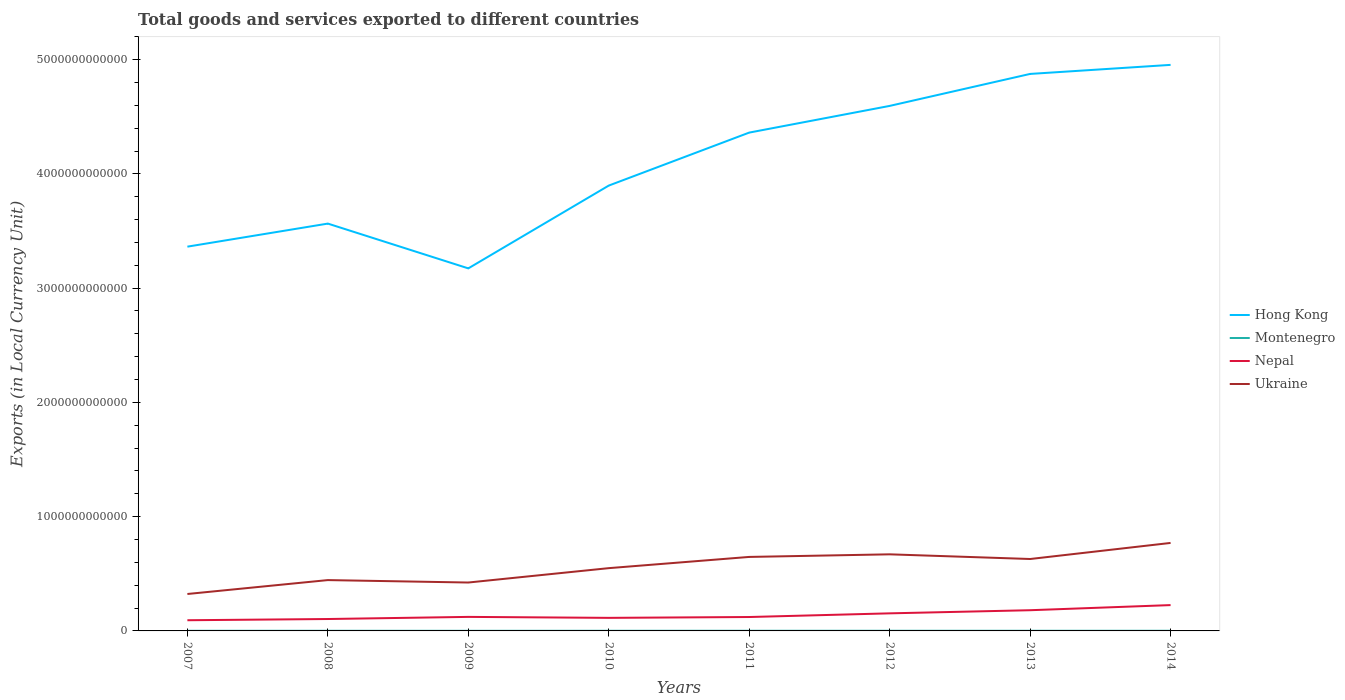How many different coloured lines are there?
Give a very brief answer. 4. Across all years, what is the maximum Amount of goods and services exports in Ukraine?
Provide a short and direct response. 3.23e+11. In which year was the Amount of goods and services exports in Nepal maximum?
Keep it short and to the point. 2007. What is the total Amount of goods and services exports in Montenegro in the graph?
Your answer should be very brief. -2.82e+07. What is the difference between the highest and the second highest Amount of goods and services exports in Montenegro?
Provide a short and direct response. 4.33e+08. What is the difference between the highest and the lowest Amount of goods and services exports in Montenegro?
Your answer should be compact. 4. How many lines are there?
Offer a very short reply. 4. What is the difference between two consecutive major ticks on the Y-axis?
Provide a short and direct response. 1.00e+12. Are the values on the major ticks of Y-axis written in scientific E-notation?
Keep it short and to the point. No. Does the graph contain any zero values?
Keep it short and to the point. No. Does the graph contain grids?
Your response must be concise. No. How are the legend labels stacked?
Your answer should be very brief. Vertical. What is the title of the graph?
Give a very brief answer. Total goods and services exported to different countries. Does "Tonga" appear as one of the legend labels in the graph?
Provide a short and direct response. No. What is the label or title of the Y-axis?
Give a very brief answer. Exports (in Local Currency Unit). What is the Exports (in Local Currency Unit) of Hong Kong in 2007?
Your response must be concise. 3.36e+12. What is the Exports (in Local Currency Unit) of Montenegro in 2007?
Your answer should be compact. 1.19e+09. What is the Exports (in Local Currency Unit) in Nepal in 2007?
Provide a succinct answer. 9.36e+1. What is the Exports (in Local Currency Unit) in Ukraine in 2007?
Provide a succinct answer. 3.23e+11. What is the Exports (in Local Currency Unit) in Hong Kong in 2008?
Offer a terse response. 3.56e+12. What is the Exports (in Local Currency Unit) of Montenegro in 2008?
Your response must be concise. 1.22e+09. What is the Exports (in Local Currency Unit) of Nepal in 2008?
Offer a very short reply. 1.04e+11. What is the Exports (in Local Currency Unit) of Ukraine in 2008?
Offer a terse response. 4.45e+11. What is the Exports (in Local Currency Unit) of Hong Kong in 2009?
Your response must be concise. 3.17e+12. What is the Exports (in Local Currency Unit) of Montenegro in 2009?
Your response must be concise. 9.57e+08. What is the Exports (in Local Currency Unit) of Nepal in 2009?
Offer a terse response. 1.23e+11. What is the Exports (in Local Currency Unit) in Ukraine in 2009?
Your answer should be compact. 4.24e+11. What is the Exports (in Local Currency Unit) of Hong Kong in 2010?
Provide a short and direct response. 3.90e+12. What is the Exports (in Local Currency Unit) in Montenegro in 2010?
Provide a succinct answer. 1.16e+09. What is the Exports (in Local Currency Unit) in Nepal in 2010?
Offer a terse response. 1.14e+11. What is the Exports (in Local Currency Unit) of Ukraine in 2010?
Give a very brief answer. 5.49e+11. What is the Exports (in Local Currency Unit) of Hong Kong in 2011?
Make the answer very short. 4.36e+12. What is the Exports (in Local Currency Unit) in Montenegro in 2011?
Make the answer very short. 1.38e+09. What is the Exports (in Local Currency Unit) of Nepal in 2011?
Make the answer very short. 1.22e+11. What is the Exports (in Local Currency Unit) of Ukraine in 2011?
Make the answer very short. 6.48e+11. What is the Exports (in Local Currency Unit) in Hong Kong in 2012?
Your answer should be very brief. 4.59e+12. What is the Exports (in Local Currency Unit) of Montenegro in 2012?
Keep it short and to the point. 1.39e+09. What is the Exports (in Local Currency Unit) in Nepal in 2012?
Give a very brief answer. 1.54e+11. What is the Exports (in Local Currency Unit) in Ukraine in 2012?
Your response must be concise. 6.70e+11. What is the Exports (in Local Currency Unit) in Hong Kong in 2013?
Your answer should be very brief. 4.87e+12. What is the Exports (in Local Currency Unit) of Montenegro in 2013?
Offer a very short reply. 1.39e+09. What is the Exports (in Local Currency Unit) in Nepal in 2013?
Provide a short and direct response. 1.81e+11. What is the Exports (in Local Currency Unit) in Ukraine in 2013?
Give a very brief answer. 6.29e+11. What is the Exports (in Local Currency Unit) in Hong Kong in 2014?
Offer a terse response. 4.95e+12. What is the Exports (in Local Currency Unit) in Montenegro in 2014?
Ensure brevity in your answer.  1.39e+09. What is the Exports (in Local Currency Unit) of Nepal in 2014?
Provide a short and direct response. 2.26e+11. What is the Exports (in Local Currency Unit) in Ukraine in 2014?
Your response must be concise. 7.70e+11. Across all years, what is the maximum Exports (in Local Currency Unit) of Hong Kong?
Keep it short and to the point. 4.95e+12. Across all years, what is the maximum Exports (in Local Currency Unit) in Montenegro?
Your answer should be very brief. 1.39e+09. Across all years, what is the maximum Exports (in Local Currency Unit) in Nepal?
Provide a succinct answer. 2.26e+11. Across all years, what is the maximum Exports (in Local Currency Unit) of Ukraine?
Your answer should be compact. 7.70e+11. Across all years, what is the minimum Exports (in Local Currency Unit) in Hong Kong?
Keep it short and to the point. 3.17e+12. Across all years, what is the minimum Exports (in Local Currency Unit) in Montenegro?
Your answer should be compact. 9.57e+08. Across all years, what is the minimum Exports (in Local Currency Unit) of Nepal?
Keep it short and to the point. 9.36e+1. Across all years, what is the minimum Exports (in Local Currency Unit) in Ukraine?
Ensure brevity in your answer.  3.23e+11. What is the total Exports (in Local Currency Unit) in Hong Kong in the graph?
Ensure brevity in your answer.  3.28e+13. What is the total Exports (in Local Currency Unit) in Montenegro in the graph?
Offer a very short reply. 1.01e+1. What is the total Exports (in Local Currency Unit) of Nepal in the graph?
Your answer should be very brief. 1.12e+12. What is the total Exports (in Local Currency Unit) in Ukraine in the graph?
Offer a terse response. 4.46e+12. What is the difference between the Exports (in Local Currency Unit) of Hong Kong in 2007 and that in 2008?
Make the answer very short. -2.02e+11. What is the difference between the Exports (in Local Currency Unit) in Montenegro in 2007 and that in 2008?
Your answer should be compact. -2.82e+07. What is the difference between the Exports (in Local Currency Unit) of Nepal in 2007 and that in 2008?
Your answer should be compact. -1.06e+1. What is the difference between the Exports (in Local Currency Unit) of Ukraine in 2007 and that in 2008?
Your response must be concise. -1.22e+11. What is the difference between the Exports (in Local Currency Unit) in Hong Kong in 2007 and that in 2009?
Offer a very short reply. 1.90e+11. What is the difference between the Exports (in Local Currency Unit) in Montenegro in 2007 and that in 2009?
Your response must be concise. 2.32e+08. What is the difference between the Exports (in Local Currency Unit) in Nepal in 2007 and that in 2009?
Your answer should be compact. -2.92e+1. What is the difference between the Exports (in Local Currency Unit) of Ukraine in 2007 and that in 2009?
Offer a very short reply. -1.00e+11. What is the difference between the Exports (in Local Currency Unit) of Hong Kong in 2007 and that in 2010?
Your answer should be compact. -5.35e+11. What is the difference between the Exports (in Local Currency Unit) of Montenegro in 2007 and that in 2010?
Offer a very short reply. 3.23e+07. What is the difference between the Exports (in Local Currency Unit) in Nepal in 2007 and that in 2010?
Provide a short and direct response. -2.07e+1. What is the difference between the Exports (in Local Currency Unit) in Ukraine in 2007 and that in 2010?
Ensure brevity in your answer.  -2.26e+11. What is the difference between the Exports (in Local Currency Unit) of Hong Kong in 2007 and that in 2011?
Offer a terse response. -9.98e+11. What is the difference between the Exports (in Local Currency Unit) in Montenegro in 2007 and that in 2011?
Your answer should be compact. -1.93e+08. What is the difference between the Exports (in Local Currency Unit) in Nepal in 2007 and that in 2011?
Make the answer very short. -2.81e+1. What is the difference between the Exports (in Local Currency Unit) of Ukraine in 2007 and that in 2011?
Keep it short and to the point. -3.24e+11. What is the difference between the Exports (in Local Currency Unit) in Hong Kong in 2007 and that in 2012?
Your answer should be very brief. -1.23e+12. What is the difference between the Exports (in Local Currency Unit) of Montenegro in 2007 and that in 2012?
Provide a succinct answer. -1.99e+08. What is the difference between the Exports (in Local Currency Unit) of Nepal in 2007 and that in 2012?
Keep it short and to the point. -6.03e+1. What is the difference between the Exports (in Local Currency Unit) of Ukraine in 2007 and that in 2012?
Provide a succinct answer. -3.47e+11. What is the difference between the Exports (in Local Currency Unit) of Hong Kong in 2007 and that in 2013?
Make the answer very short. -1.51e+12. What is the difference between the Exports (in Local Currency Unit) in Montenegro in 2007 and that in 2013?
Give a very brief answer. -2.00e+08. What is the difference between the Exports (in Local Currency Unit) in Nepal in 2007 and that in 2013?
Your response must be concise. -8.76e+1. What is the difference between the Exports (in Local Currency Unit) in Ukraine in 2007 and that in 2013?
Offer a terse response. -3.06e+11. What is the difference between the Exports (in Local Currency Unit) in Hong Kong in 2007 and that in 2014?
Make the answer very short. -1.59e+12. What is the difference between the Exports (in Local Currency Unit) of Montenegro in 2007 and that in 2014?
Your answer should be compact. -1.98e+08. What is the difference between the Exports (in Local Currency Unit) in Nepal in 2007 and that in 2014?
Provide a short and direct response. -1.32e+11. What is the difference between the Exports (in Local Currency Unit) in Ukraine in 2007 and that in 2014?
Offer a terse response. -4.47e+11. What is the difference between the Exports (in Local Currency Unit) of Hong Kong in 2008 and that in 2009?
Your answer should be very brief. 3.92e+11. What is the difference between the Exports (in Local Currency Unit) of Montenegro in 2008 and that in 2009?
Provide a succinct answer. 2.61e+08. What is the difference between the Exports (in Local Currency Unit) of Nepal in 2008 and that in 2009?
Give a very brief answer. -1.85e+1. What is the difference between the Exports (in Local Currency Unit) of Ukraine in 2008 and that in 2009?
Offer a very short reply. 2.13e+1. What is the difference between the Exports (in Local Currency Unit) in Hong Kong in 2008 and that in 2010?
Give a very brief answer. -3.33e+11. What is the difference between the Exports (in Local Currency Unit) in Montenegro in 2008 and that in 2010?
Provide a short and direct response. 6.05e+07. What is the difference between the Exports (in Local Currency Unit) of Nepal in 2008 and that in 2010?
Offer a terse response. -1.01e+1. What is the difference between the Exports (in Local Currency Unit) of Ukraine in 2008 and that in 2010?
Provide a short and direct response. -1.05e+11. What is the difference between the Exports (in Local Currency Unit) of Hong Kong in 2008 and that in 2011?
Provide a short and direct response. -7.96e+11. What is the difference between the Exports (in Local Currency Unit) of Montenegro in 2008 and that in 2011?
Your response must be concise. -1.64e+08. What is the difference between the Exports (in Local Currency Unit) in Nepal in 2008 and that in 2011?
Offer a terse response. -1.75e+1. What is the difference between the Exports (in Local Currency Unit) of Ukraine in 2008 and that in 2011?
Offer a very short reply. -2.03e+11. What is the difference between the Exports (in Local Currency Unit) in Hong Kong in 2008 and that in 2012?
Your response must be concise. -1.03e+12. What is the difference between the Exports (in Local Currency Unit) in Montenegro in 2008 and that in 2012?
Ensure brevity in your answer.  -1.71e+08. What is the difference between the Exports (in Local Currency Unit) of Nepal in 2008 and that in 2012?
Make the answer very short. -4.97e+1. What is the difference between the Exports (in Local Currency Unit) in Ukraine in 2008 and that in 2012?
Provide a short and direct response. -2.25e+11. What is the difference between the Exports (in Local Currency Unit) in Hong Kong in 2008 and that in 2013?
Ensure brevity in your answer.  -1.31e+12. What is the difference between the Exports (in Local Currency Unit) in Montenegro in 2008 and that in 2013?
Your answer should be very brief. -1.72e+08. What is the difference between the Exports (in Local Currency Unit) of Nepal in 2008 and that in 2013?
Ensure brevity in your answer.  -7.70e+1. What is the difference between the Exports (in Local Currency Unit) in Ukraine in 2008 and that in 2013?
Your response must be concise. -1.85e+11. What is the difference between the Exports (in Local Currency Unit) of Hong Kong in 2008 and that in 2014?
Ensure brevity in your answer.  -1.39e+12. What is the difference between the Exports (in Local Currency Unit) in Montenegro in 2008 and that in 2014?
Keep it short and to the point. -1.70e+08. What is the difference between the Exports (in Local Currency Unit) of Nepal in 2008 and that in 2014?
Give a very brief answer. -1.22e+11. What is the difference between the Exports (in Local Currency Unit) in Ukraine in 2008 and that in 2014?
Provide a succinct answer. -3.25e+11. What is the difference between the Exports (in Local Currency Unit) of Hong Kong in 2009 and that in 2010?
Provide a succinct answer. -7.25e+11. What is the difference between the Exports (in Local Currency Unit) in Montenegro in 2009 and that in 2010?
Provide a succinct answer. -2.00e+08. What is the difference between the Exports (in Local Currency Unit) of Nepal in 2009 and that in 2010?
Your answer should be compact. 8.44e+09. What is the difference between the Exports (in Local Currency Unit) in Ukraine in 2009 and that in 2010?
Offer a very short reply. -1.26e+11. What is the difference between the Exports (in Local Currency Unit) of Hong Kong in 2009 and that in 2011?
Your answer should be very brief. -1.19e+12. What is the difference between the Exports (in Local Currency Unit) in Montenegro in 2009 and that in 2011?
Provide a short and direct response. -4.25e+08. What is the difference between the Exports (in Local Currency Unit) in Nepal in 2009 and that in 2011?
Provide a short and direct response. 1.02e+09. What is the difference between the Exports (in Local Currency Unit) of Ukraine in 2009 and that in 2011?
Make the answer very short. -2.24e+11. What is the difference between the Exports (in Local Currency Unit) of Hong Kong in 2009 and that in 2012?
Your response must be concise. -1.42e+12. What is the difference between the Exports (in Local Currency Unit) in Montenegro in 2009 and that in 2012?
Make the answer very short. -4.32e+08. What is the difference between the Exports (in Local Currency Unit) of Nepal in 2009 and that in 2012?
Your answer should be very brief. -3.11e+1. What is the difference between the Exports (in Local Currency Unit) in Ukraine in 2009 and that in 2012?
Keep it short and to the point. -2.47e+11. What is the difference between the Exports (in Local Currency Unit) of Hong Kong in 2009 and that in 2013?
Keep it short and to the point. -1.70e+12. What is the difference between the Exports (in Local Currency Unit) of Montenegro in 2009 and that in 2013?
Give a very brief answer. -4.33e+08. What is the difference between the Exports (in Local Currency Unit) of Nepal in 2009 and that in 2013?
Make the answer very short. -5.84e+1. What is the difference between the Exports (in Local Currency Unit) of Ukraine in 2009 and that in 2013?
Offer a very short reply. -2.06e+11. What is the difference between the Exports (in Local Currency Unit) in Hong Kong in 2009 and that in 2014?
Keep it short and to the point. -1.78e+12. What is the difference between the Exports (in Local Currency Unit) in Montenegro in 2009 and that in 2014?
Your answer should be compact. -4.31e+08. What is the difference between the Exports (in Local Currency Unit) in Nepal in 2009 and that in 2014?
Ensure brevity in your answer.  -1.03e+11. What is the difference between the Exports (in Local Currency Unit) in Ukraine in 2009 and that in 2014?
Provide a succinct answer. -3.47e+11. What is the difference between the Exports (in Local Currency Unit) of Hong Kong in 2010 and that in 2011?
Give a very brief answer. -4.64e+11. What is the difference between the Exports (in Local Currency Unit) in Montenegro in 2010 and that in 2011?
Offer a very short reply. -2.25e+08. What is the difference between the Exports (in Local Currency Unit) in Nepal in 2010 and that in 2011?
Your answer should be compact. -7.42e+09. What is the difference between the Exports (in Local Currency Unit) in Ukraine in 2010 and that in 2011?
Ensure brevity in your answer.  -9.82e+1. What is the difference between the Exports (in Local Currency Unit) of Hong Kong in 2010 and that in 2012?
Offer a very short reply. -6.97e+11. What is the difference between the Exports (in Local Currency Unit) in Montenegro in 2010 and that in 2012?
Give a very brief answer. -2.32e+08. What is the difference between the Exports (in Local Currency Unit) in Nepal in 2010 and that in 2012?
Make the answer very short. -3.96e+1. What is the difference between the Exports (in Local Currency Unit) in Ukraine in 2010 and that in 2012?
Keep it short and to the point. -1.21e+11. What is the difference between the Exports (in Local Currency Unit) in Hong Kong in 2010 and that in 2013?
Provide a succinct answer. -9.77e+11. What is the difference between the Exports (in Local Currency Unit) of Montenegro in 2010 and that in 2013?
Your answer should be very brief. -2.32e+08. What is the difference between the Exports (in Local Currency Unit) in Nepal in 2010 and that in 2013?
Make the answer very short. -6.69e+1. What is the difference between the Exports (in Local Currency Unit) of Ukraine in 2010 and that in 2013?
Your answer should be compact. -8.00e+1. What is the difference between the Exports (in Local Currency Unit) in Hong Kong in 2010 and that in 2014?
Your answer should be very brief. -1.06e+12. What is the difference between the Exports (in Local Currency Unit) of Montenegro in 2010 and that in 2014?
Keep it short and to the point. -2.30e+08. What is the difference between the Exports (in Local Currency Unit) of Nepal in 2010 and that in 2014?
Your answer should be compact. -1.12e+11. What is the difference between the Exports (in Local Currency Unit) in Ukraine in 2010 and that in 2014?
Your answer should be very brief. -2.21e+11. What is the difference between the Exports (in Local Currency Unit) in Hong Kong in 2011 and that in 2012?
Keep it short and to the point. -2.34e+11. What is the difference between the Exports (in Local Currency Unit) of Montenegro in 2011 and that in 2012?
Your answer should be compact. -6.83e+06. What is the difference between the Exports (in Local Currency Unit) of Nepal in 2011 and that in 2012?
Offer a terse response. -3.21e+1. What is the difference between the Exports (in Local Currency Unit) in Ukraine in 2011 and that in 2012?
Provide a succinct answer. -2.27e+1. What is the difference between the Exports (in Local Currency Unit) of Hong Kong in 2011 and that in 2013?
Make the answer very short. -5.13e+11. What is the difference between the Exports (in Local Currency Unit) of Montenegro in 2011 and that in 2013?
Offer a very short reply. -7.53e+06. What is the difference between the Exports (in Local Currency Unit) in Nepal in 2011 and that in 2013?
Your answer should be very brief. -5.95e+1. What is the difference between the Exports (in Local Currency Unit) in Ukraine in 2011 and that in 2013?
Your response must be concise. 1.82e+1. What is the difference between the Exports (in Local Currency Unit) in Hong Kong in 2011 and that in 2014?
Make the answer very short. -5.93e+11. What is the difference between the Exports (in Local Currency Unit) in Montenegro in 2011 and that in 2014?
Your answer should be very brief. -5.54e+06. What is the difference between the Exports (in Local Currency Unit) of Nepal in 2011 and that in 2014?
Offer a terse response. -1.04e+11. What is the difference between the Exports (in Local Currency Unit) in Ukraine in 2011 and that in 2014?
Your answer should be compact. -1.23e+11. What is the difference between the Exports (in Local Currency Unit) in Hong Kong in 2012 and that in 2013?
Make the answer very short. -2.80e+11. What is the difference between the Exports (in Local Currency Unit) of Montenegro in 2012 and that in 2013?
Offer a very short reply. -6.99e+05. What is the difference between the Exports (in Local Currency Unit) of Nepal in 2012 and that in 2013?
Offer a very short reply. -2.73e+1. What is the difference between the Exports (in Local Currency Unit) of Ukraine in 2012 and that in 2013?
Offer a terse response. 4.09e+1. What is the difference between the Exports (in Local Currency Unit) of Hong Kong in 2012 and that in 2014?
Keep it short and to the point. -3.59e+11. What is the difference between the Exports (in Local Currency Unit) of Montenegro in 2012 and that in 2014?
Your answer should be compact. 1.29e+06. What is the difference between the Exports (in Local Currency Unit) of Nepal in 2012 and that in 2014?
Your answer should be compact. -7.22e+1. What is the difference between the Exports (in Local Currency Unit) of Ukraine in 2012 and that in 2014?
Offer a very short reply. -9.98e+1. What is the difference between the Exports (in Local Currency Unit) of Hong Kong in 2013 and that in 2014?
Make the answer very short. -7.92e+1. What is the difference between the Exports (in Local Currency Unit) in Montenegro in 2013 and that in 2014?
Make the answer very short. 1.99e+06. What is the difference between the Exports (in Local Currency Unit) of Nepal in 2013 and that in 2014?
Ensure brevity in your answer.  -4.48e+1. What is the difference between the Exports (in Local Currency Unit) of Ukraine in 2013 and that in 2014?
Your answer should be compact. -1.41e+11. What is the difference between the Exports (in Local Currency Unit) in Hong Kong in 2007 and the Exports (in Local Currency Unit) in Montenegro in 2008?
Ensure brevity in your answer.  3.36e+12. What is the difference between the Exports (in Local Currency Unit) of Hong Kong in 2007 and the Exports (in Local Currency Unit) of Nepal in 2008?
Provide a short and direct response. 3.26e+12. What is the difference between the Exports (in Local Currency Unit) in Hong Kong in 2007 and the Exports (in Local Currency Unit) in Ukraine in 2008?
Offer a terse response. 2.92e+12. What is the difference between the Exports (in Local Currency Unit) of Montenegro in 2007 and the Exports (in Local Currency Unit) of Nepal in 2008?
Offer a terse response. -1.03e+11. What is the difference between the Exports (in Local Currency Unit) in Montenegro in 2007 and the Exports (in Local Currency Unit) in Ukraine in 2008?
Make the answer very short. -4.44e+11. What is the difference between the Exports (in Local Currency Unit) of Nepal in 2007 and the Exports (in Local Currency Unit) of Ukraine in 2008?
Provide a succinct answer. -3.51e+11. What is the difference between the Exports (in Local Currency Unit) of Hong Kong in 2007 and the Exports (in Local Currency Unit) of Montenegro in 2009?
Provide a short and direct response. 3.36e+12. What is the difference between the Exports (in Local Currency Unit) of Hong Kong in 2007 and the Exports (in Local Currency Unit) of Nepal in 2009?
Provide a succinct answer. 3.24e+12. What is the difference between the Exports (in Local Currency Unit) of Hong Kong in 2007 and the Exports (in Local Currency Unit) of Ukraine in 2009?
Your answer should be compact. 2.94e+12. What is the difference between the Exports (in Local Currency Unit) in Montenegro in 2007 and the Exports (in Local Currency Unit) in Nepal in 2009?
Make the answer very short. -1.22e+11. What is the difference between the Exports (in Local Currency Unit) in Montenegro in 2007 and the Exports (in Local Currency Unit) in Ukraine in 2009?
Provide a succinct answer. -4.22e+11. What is the difference between the Exports (in Local Currency Unit) of Nepal in 2007 and the Exports (in Local Currency Unit) of Ukraine in 2009?
Your response must be concise. -3.30e+11. What is the difference between the Exports (in Local Currency Unit) in Hong Kong in 2007 and the Exports (in Local Currency Unit) in Montenegro in 2010?
Make the answer very short. 3.36e+12. What is the difference between the Exports (in Local Currency Unit) in Hong Kong in 2007 and the Exports (in Local Currency Unit) in Nepal in 2010?
Your response must be concise. 3.25e+12. What is the difference between the Exports (in Local Currency Unit) of Hong Kong in 2007 and the Exports (in Local Currency Unit) of Ukraine in 2010?
Keep it short and to the point. 2.81e+12. What is the difference between the Exports (in Local Currency Unit) of Montenegro in 2007 and the Exports (in Local Currency Unit) of Nepal in 2010?
Give a very brief answer. -1.13e+11. What is the difference between the Exports (in Local Currency Unit) in Montenegro in 2007 and the Exports (in Local Currency Unit) in Ukraine in 2010?
Make the answer very short. -5.48e+11. What is the difference between the Exports (in Local Currency Unit) of Nepal in 2007 and the Exports (in Local Currency Unit) of Ukraine in 2010?
Your answer should be very brief. -4.56e+11. What is the difference between the Exports (in Local Currency Unit) of Hong Kong in 2007 and the Exports (in Local Currency Unit) of Montenegro in 2011?
Your answer should be very brief. 3.36e+12. What is the difference between the Exports (in Local Currency Unit) in Hong Kong in 2007 and the Exports (in Local Currency Unit) in Nepal in 2011?
Ensure brevity in your answer.  3.24e+12. What is the difference between the Exports (in Local Currency Unit) of Hong Kong in 2007 and the Exports (in Local Currency Unit) of Ukraine in 2011?
Your response must be concise. 2.72e+12. What is the difference between the Exports (in Local Currency Unit) in Montenegro in 2007 and the Exports (in Local Currency Unit) in Nepal in 2011?
Provide a short and direct response. -1.21e+11. What is the difference between the Exports (in Local Currency Unit) in Montenegro in 2007 and the Exports (in Local Currency Unit) in Ukraine in 2011?
Offer a terse response. -6.46e+11. What is the difference between the Exports (in Local Currency Unit) in Nepal in 2007 and the Exports (in Local Currency Unit) in Ukraine in 2011?
Ensure brevity in your answer.  -5.54e+11. What is the difference between the Exports (in Local Currency Unit) of Hong Kong in 2007 and the Exports (in Local Currency Unit) of Montenegro in 2012?
Give a very brief answer. 3.36e+12. What is the difference between the Exports (in Local Currency Unit) in Hong Kong in 2007 and the Exports (in Local Currency Unit) in Nepal in 2012?
Offer a very short reply. 3.21e+12. What is the difference between the Exports (in Local Currency Unit) of Hong Kong in 2007 and the Exports (in Local Currency Unit) of Ukraine in 2012?
Provide a succinct answer. 2.69e+12. What is the difference between the Exports (in Local Currency Unit) in Montenegro in 2007 and the Exports (in Local Currency Unit) in Nepal in 2012?
Your answer should be compact. -1.53e+11. What is the difference between the Exports (in Local Currency Unit) in Montenegro in 2007 and the Exports (in Local Currency Unit) in Ukraine in 2012?
Provide a succinct answer. -6.69e+11. What is the difference between the Exports (in Local Currency Unit) in Nepal in 2007 and the Exports (in Local Currency Unit) in Ukraine in 2012?
Offer a terse response. -5.77e+11. What is the difference between the Exports (in Local Currency Unit) in Hong Kong in 2007 and the Exports (in Local Currency Unit) in Montenegro in 2013?
Your answer should be very brief. 3.36e+12. What is the difference between the Exports (in Local Currency Unit) in Hong Kong in 2007 and the Exports (in Local Currency Unit) in Nepal in 2013?
Make the answer very short. 3.18e+12. What is the difference between the Exports (in Local Currency Unit) of Hong Kong in 2007 and the Exports (in Local Currency Unit) of Ukraine in 2013?
Provide a succinct answer. 2.73e+12. What is the difference between the Exports (in Local Currency Unit) of Montenegro in 2007 and the Exports (in Local Currency Unit) of Nepal in 2013?
Offer a terse response. -1.80e+11. What is the difference between the Exports (in Local Currency Unit) of Montenegro in 2007 and the Exports (in Local Currency Unit) of Ukraine in 2013?
Provide a short and direct response. -6.28e+11. What is the difference between the Exports (in Local Currency Unit) in Nepal in 2007 and the Exports (in Local Currency Unit) in Ukraine in 2013?
Your answer should be very brief. -5.36e+11. What is the difference between the Exports (in Local Currency Unit) in Hong Kong in 2007 and the Exports (in Local Currency Unit) in Montenegro in 2014?
Provide a succinct answer. 3.36e+12. What is the difference between the Exports (in Local Currency Unit) of Hong Kong in 2007 and the Exports (in Local Currency Unit) of Nepal in 2014?
Provide a succinct answer. 3.14e+12. What is the difference between the Exports (in Local Currency Unit) of Hong Kong in 2007 and the Exports (in Local Currency Unit) of Ukraine in 2014?
Ensure brevity in your answer.  2.59e+12. What is the difference between the Exports (in Local Currency Unit) of Montenegro in 2007 and the Exports (in Local Currency Unit) of Nepal in 2014?
Provide a succinct answer. -2.25e+11. What is the difference between the Exports (in Local Currency Unit) in Montenegro in 2007 and the Exports (in Local Currency Unit) in Ukraine in 2014?
Offer a very short reply. -7.69e+11. What is the difference between the Exports (in Local Currency Unit) of Nepal in 2007 and the Exports (in Local Currency Unit) of Ukraine in 2014?
Give a very brief answer. -6.77e+11. What is the difference between the Exports (in Local Currency Unit) in Hong Kong in 2008 and the Exports (in Local Currency Unit) in Montenegro in 2009?
Provide a short and direct response. 3.56e+12. What is the difference between the Exports (in Local Currency Unit) of Hong Kong in 2008 and the Exports (in Local Currency Unit) of Nepal in 2009?
Provide a short and direct response. 3.44e+12. What is the difference between the Exports (in Local Currency Unit) in Hong Kong in 2008 and the Exports (in Local Currency Unit) in Ukraine in 2009?
Offer a terse response. 3.14e+12. What is the difference between the Exports (in Local Currency Unit) in Montenegro in 2008 and the Exports (in Local Currency Unit) in Nepal in 2009?
Your response must be concise. -1.22e+11. What is the difference between the Exports (in Local Currency Unit) in Montenegro in 2008 and the Exports (in Local Currency Unit) in Ukraine in 2009?
Your response must be concise. -4.22e+11. What is the difference between the Exports (in Local Currency Unit) in Nepal in 2008 and the Exports (in Local Currency Unit) in Ukraine in 2009?
Your response must be concise. -3.19e+11. What is the difference between the Exports (in Local Currency Unit) of Hong Kong in 2008 and the Exports (in Local Currency Unit) of Montenegro in 2010?
Ensure brevity in your answer.  3.56e+12. What is the difference between the Exports (in Local Currency Unit) in Hong Kong in 2008 and the Exports (in Local Currency Unit) in Nepal in 2010?
Your response must be concise. 3.45e+12. What is the difference between the Exports (in Local Currency Unit) in Hong Kong in 2008 and the Exports (in Local Currency Unit) in Ukraine in 2010?
Provide a succinct answer. 3.02e+12. What is the difference between the Exports (in Local Currency Unit) of Montenegro in 2008 and the Exports (in Local Currency Unit) of Nepal in 2010?
Make the answer very short. -1.13e+11. What is the difference between the Exports (in Local Currency Unit) in Montenegro in 2008 and the Exports (in Local Currency Unit) in Ukraine in 2010?
Give a very brief answer. -5.48e+11. What is the difference between the Exports (in Local Currency Unit) of Nepal in 2008 and the Exports (in Local Currency Unit) of Ukraine in 2010?
Your response must be concise. -4.45e+11. What is the difference between the Exports (in Local Currency Unit) in Hong Kong in 2008 and the Exports (in Local Currency Unit) in Montenegro in 2011?
Provide a short and direct response. 3.56e+12. What is the difference between the Exports (in Local Currency Unit) in Hong Kong in 2008 and the Exports (in Local Currency Unit) in Nepal in 2011?
Ensure brevity in your answer.  3.44e+12. What is the difference between the Exports (in Local Currency Unit) of Hong Kong in 2008 and the Exports (in Local Currency Unit) of Ukraine in 2011?
Your response must be concise. 2.92e+12. What is the difference between the Exports (in Local Currency Unit) in Montenegro in 2008 and the Exports (in Local Currency Unit) in Nepal in 2011?
Keep it short and to the point. -1.20e+11. What is the difference between the Exports (in Local Currency Unit) in Montenegro in 2008 and the Exports (in Local Currency Unit) in Ukraine in 2011?
Your answer should be compact. -6.46e+11. What is the difference between the Exports (in Local Currency Unit) in Nepal in 2008 and the Exports (in Local Currency Unit) in Ukraine in 2011?
Provide a short and direct response. -5.43e+11. What is the difference between the Exports (in Local Currency Unit) of Hong Kong in 2008 and the Exports (in Local Currency Unit) of Montenegro in 2012?
Your answer should be very brief. 3.56e+12. What is the difference between the Exports (in Local Currency Unit) in Hong Kong in 2008 and the Exports (in Local Currency Unit) in Nepal in 2012?
Your answer should be very brief. 3.41e+12. What is the difference between the Exports (in Local Currency Unit) of Hong Kong in 2008 and the Exports (in Local Currency Unit) of Ukraine in 2012?
Offer a very short reply. 2.89e+12. What is the difference between the Exports (in Local Currency Unit) of Montenegro in 2008 and the Exports (in Local Currency Unit) of Nepal in 2012?
Make the answer very short. -1.53e+11. What is the difference between the Exports (in Local Currency Unit) of Montenegro in 2008 and the Exports (in Local Currency Unit) of Ukraine in 2012?
Provide a short and direct response. -6.69e+11. What is the difference between the Exports (in Local Currency Unit) in Nepal in 2008 and the Exports (in Local Currency Unit) in Ukraine in 2012?
Offer a very short reply. -5.66e+11. What is the difference between the Exports (in Local Currency Unit) of Hong Kong in 2008 and the Exports (in Local Currency Unit) of Montenegro in 2013?
Your response must be concise. 3.56e+12. What is the difference between the Exports (in Local Currency Unit) in Hong Kong in 2008 and the Exports (in Local Currency Unit) in Nepal in 2013?
Keep it short and to the point. 3.38e+12. What is the difference between the Exports (in Local Currency Unit) of Hong Kong in 2008 and the Exports (in Local Currency Unit) of Ukraine in 2013?
Offer a terse response. 2.94e+12. What is the difference between the Exports (in Local Currency Unit) of Montenegro in 2008 and the Exports (in Local Currency Unit) of Nepal in 2013?
Provide a succinct answer. -1.80e+11. What is the difference between the Exports (in Local Currency Unit) in Montenegro in 2008 and the Exports (in Local Currency Unit) in Ukraine in 2013?
Give a very brief answer. -6.28e+11. What is the difference between the Exports (in Local Currency Unit) of Nepal in 2008 and the Exports (in Local Currency Unit) of Ukraine in 2013?
Your response must be concise. -5.25e+11. What is the difference between the Exports (in Local Currency Unit) in Hong Kong in 2008 and the Exports (in Local Currency Unit) in Montenegro in 2014?
Your response must be concise. 3.56e+12. What is the difference between the Exports (in Local Currency Unit) of Hong Kong in 2008 and the Exports (in Local Currency Unit) of Nepal in 2014?
Keep it short and to the point. 3.34e+12. What is the difference between the Exports (in Local Currency Unit) of Hong Kong in 2008 and the Exports (in Local Currency Unit) of Ukraine in 2014?
Your answer should be compact. 2.79e+12. What is the difference between the Exports (in Local Currency Unit) in Montenegro in 2008 and the Exports (in Local Currency Unit) in Nepal in 2014?
Ensure brevity in your answer.  -2.25e+11. What is the difference between the Exports (in Local Currency Unit) of Montenegro in 2008 and the Exports (in Local Currency Unit) of Ukraine in 2014?
Your answer should be very brief. -7.69e+11. What is the difference between the Exports (in Local Currency Unit) in Nepal in 2008 and the Exports (in Local Currency Unit) in Ukraine in 2014?
Provide a succinct answer. -6.66e+11. What is the difference between the Exports (in Local Currency Unit) of Hong Kong in 2009 and the Exports (in Local Currency Unit) of Montenegro in 2010?
Offer a terse response. 3.17e+12. What is the difference between the Exports (in Local Currency Unit) in Hong Kong in 2009 and the Exports (in Local Currency Unit) in Nepal in 2010?
Your response must be concise. 3.06e+12. What is the difference between the Exports (in Local Currency Unit) of Hong Kong in 2009 and the Exports (in Local Currency Unit) of Ukraine in 2010?
Offer a terse response. 2.62e+12. What is the difference between the Exports (in Local Currency Unit) in Montenegro in 2009 and the Exports (in Local Currency Unit) in Nepal in 2010?
Your response must be concise. -1.13e+11. What is the difference between the Exports (in Local Currency Unit) in Montenegro in 2009 and the Exports (in Local Currency Unit) in Ukraine in 2010?
Give a very brief answer. -5.48e+11. What is the difference between the Exports (in Local Currency Unit) of Nepal in 2009 and the Exports (in Local Currency Unit) of Ukraine in 2010?
Offer a very short reply. -4.27e+11. What is the difference between the Exports (in Local Currency Unit) of Hong Kong in 2009 and the Exports (in Local Currency Unit) of Montenegro in 2011?
Make the answer very short. 3.17e+12. What is the difference between the Exports (in Local Currency Unit) in Hong Kong in 2009 and the Exports (in Local Currency Unit) in Nepal in 2011?
Your answer should be very brief. 3.05e+12. What is the difference between the Exports (in Local Currency Unit) in Hong Kong in 2009 and the Exports (in Local Currency Unit) in Ukraine in 2011?
Your response must be concise. 2.53e+12. What is the difference between the Exports (in Local Currency Unit) in Montenegro in 2009 and the Exports (in Local Currency Unit) in Nepal in 2011?
Provide a short and direct response. -1.21e+11. What is the difference between the Exports (in Local Currency Unit) in Montenegro in 2009 and the Exports (in Local Currency Unit) in Ukraine in 2011?
Ensure brevity in your answer.  -6.47e+11. What is the difference between the Exports (in Local Currency Unit) of Nepal in 2009 and the Exports (in Local Currency Unit) of Ukraine in 2011?
Offer a very short reply. -5.25e+11. What is the difference between the Exports (in Local Currency Unit) in Hong Kong in 2009 and the Exports (in Local Currency Unit) in Montenegro in 2012?
Make the answer very short. 3.17e+12. What is the difference between the Exports (in Local Currency Unit) in Hong Kong in 2009 and the Exports (in Local Currency Unit) in Nepal in 2012?
Provide a short and direct response. 3.02e+12. What is the difference between the Exports (in Local Currency Unit) in Hong Kong in 2009 and the Exports (in Local Currency Unit) in Ukraine in 2012?
Offer a very short reply. 2.50e+12. What is the difference between the Exports (in Local Currency Unit) in Montenegro in 2009 and the Exports (in Local Currency Unit) in Nepal in 2012?
Your answer should be compact. -1.53e+11. What is the difference between the Exports (in Local Currency Unit) of Montenegro in 2009 and the Exports (in Local Currency Unit) of Ukraine in 2012?
Your answer should be compact. -6.69e+11. What is the difference between the Exports (in Local Currency Unit) in Nepal in 2009 and the Exports (in Local Currency Unit) in Ukraine in 2012?
Keep it short and to the point. -5.48e+11. What is the difference between the Exports (in Local Currency Unit) of Hong Kong in 2009 and the Exports (in Local Currency Unit) of Montenegro in 2013?
Offer a terse response. 3.17e+12. What is the difference between the Exports (in Local Currency Unit) of Hong Kong in 2009 and the Exports (in Local Currency Unit) of Nepal in 2013?
Your answer should be compact. 2.99e+12. What is the difference between the Exports (in Local Currency Unit) of Hong Kong in 2009 and the Exports (in Local Currency Unit) of Ukraine in 2013?
Offer a terse response. 2.54e+12. What is the difference between the Exports (in Local Currency Unit) of Montenegro in 2009 and the Exports (in Local Currency Unit) of Nepal in 2013?
Ensure brevity in your answer.  -1.80e+11. What is the difference between the Exports (in Local Currency Unit) of Montenegro in 2009 and the Exports (in Local Currency Unit) of Ukraine in 2013?
Provide a short and direct response. -6.28e+11. What is the difference between the Exports (in Local Currency Unit) in Nepal in 2009 and the Exports (in Local Currency Unit) in Ukraine in 2013?
Provide a short and direct response. -5.07e+11. What is the difference between the Exports (in Local Currency Unit) in Hong Kong in 2009 and the Exports (in Local Currency Unit) in Montenegro in 2014?
Keep it short and to the point. 3.17e+12. What is the difference between the Exports (in Local Currency Unit) in Hong Kong in 2009 and the Exports (in Local Currency Unit) in Nepal in 2014?
Offer a terse response. 2.95e+12. What is the difference between the Exports (in Local Currency Unit) of Hong Kong in 2009 and the Exports (in Local Currency Unit) of Ukraine in 2014?
Offer a very short reply. 2.40e+12. What is the difference between the Exports (in Local Currency Unit) of Montenegro in 2009 and the Exports (in Local Currency Unit) of Nepal in 2014?
Your answer should be compact. -2.25e+11. What is the difference between the Exports (in Local Currency Unit) of Montenegro in 2009 and the Exports (in Local Currency Unit) of Ukraine in 2014?
Your answer should be very brief. -7.69e+11. What is the difference between the Exports (in Local Currency Unit) of Nepal in 2009 and the Exports (in Local Currency Unit) of Ukraine in 2014?
Ensure brevity in your answer.  -6.47e+11. What is the difference between the Exports (in Local Currency Unit) in Hong Kong in 2010 and the Exports (in Local Currency Unit) in Montenegro in 2011?
Offer a very short reply. 3.90e+12. What is the difference between the Exports (in Local Currency Unit) in Hong Kong in 2010 and the Exports (in Local Currency Unit) in Nepal in 2011?
Keep it short and to the point. 3.78e+12. What is the difference between the Exports (in Local Currency Unit) in Hong Kong in 2010 and the Exports (in Local Currency Unit) in Ukraine in 2011?
Provide a succinct answer. 3.25e+12. What is the difference between the Exports (in Local Currency Unit) of Montenegro in 2010 and the Exports (in Local Currency Unit) of Nepal in 2011?
Your answer should be compact. -1.21e+11. What is the difference between the Exports (in Local Currency Unit) of Montenegro in 2010 and the Exports (in Local Currency Unit) of Ukraine in 2011?
Provide a succinct answer. -6.46e+11. What is the difference between the Exports (in Local Currency Unit) in Nepal in 2010 and the Exports (in Local Currency Unit) in Ukraine in 2011?
Your answer should be very brief. -5.33e+11. What is the difference between the Exports (in Local Currency Unit) of Hong Kong in 2010 and the Exports (in Local Currency Unit) of Montenegro in 2012?
Your response must be concise. 3.90e+12. What is the difference between the Exports (in Local Currency Unit) of Hong Kong in 2010 and the Exports (in Local Currency Unit) of Nepal in 2012?
Provide a succinct answer. 3.74e+12. What is the difference between the Exports (in Local Currency Unit) of Hong Kong in 2010 and the Exports (in Local Currency Unit) of Ukraine in 2012?
Provide a short and direct response. 3.23e+12. What is the difference between the Exports (in Local Currency Unit) of Montenegro in 2010 and the Exports (in Local Currency Unit) of Nepal in 2012?
Keep it short and to the point. -1.53e+11. What is the difference between the Exports (in Local Currency Unit) of Montenegro in 2010 and the Exports (in Local Currency Unit) of Ukraine in 2012?
Your answer should be compact. -6.69e+11. What is the difference between the Exports (in Local Currency Unit) of Nepal in 2010 and the Exports (in Local Currency Unit) of Ukraine in 2012?
Keep it short and to the point. -5.56e+11. What is the difference between the Exports (in Local Currency Unit) in Hong Kong in 2010 and the Exports (in Local Currency Unit) in Montenegro in 2013?
Your response must be concise. 3.90e+12. What is the difference between the Exports (in Local Currency Unit) in Hong Kong in 2010 and the Exports (in Local Currency Unit) in Nepal in 2013?
Offer a terse response. 3.72e+12. What is the difference between the Exports (in Local Currency Unit) of Hong Kong in 2010 and the Exports (in Local Currency Unit) of Ukraine in 2013?
Give a very brief answer. 3.27e+12. What is the difference between the Exports (in Local Currency Unit) in Montenegro in 2010 and the Exports (in Local Currency Unit) in Nepal in 2013?
Make the answer very short. -1.80e+11. What is the difference between the Exports (in Local Currency Unit) in Montenegro in 2010 and the Exports (in Local Currency Unit) in Ukraine in 2013?
Make the answer very short. -6.28e+11. What is the difference between the Exports (in Local Currency Unit) of Nepal in 2010 and the Exports (in Local Currency Unit) of Ukraine in 2013?
Your answer should be very brief. -5.15e+11. What is the difference between the Exports (in Local Currency Unit) of Hong Kong in 2010 and the Exports (in Local Currency Unit) of Montenegro in 2014?
Keep it short and to the point. 3.90e+12. What is the difference between the Exports (in Local Currency Unit) of Hong Kong in 2010 and the Exports (in Local Currency Unit) of Nepal in 2014?
Make the answer very short. 3.67e+12. What is the difference between the Exports (in Local Currency Unit) of Hong Kong in 2010 and the Exports (in Local Currency Unit) of Ukraine in 2014?
Provide a succinct answer. 3.13e+12. What is the difference between the Exports (in Local Currency Unit) in Montenegro in 2010 and the Exports (in Local Currency Unit) in Nepal in 2014?
Provide a succinct answer. -2.25e+11. What is the difference between the Exports (in Local Currency Unit) in Montenegro in 2010 and the Exports (in Local Currency Unit) in Ukraine in 2014?
Give a very brief answer. -7.69e+11. What is the difference between the Exports (in Local Currency Unit) of Nepal in 2010 and the Exports (in Local Currency Unit) of Ukraine in 2014?
Your response must be concise. -6.56e+11. What is the difference between the Exports (in Local Currency Unit) in Hong Kong in 2011 and the Exports (in Local Currency Unit) in Montenegro in 2012?
Your answer should be very brief. 4.36e+12. What is the difference between the Exports (in Local Currency Unit) of Hong Kong in 2011 and the Exports (in Local Currency Unit) of Nepal in 2012?
Your answer should be very brief. 4.21e+12. What is the difference between the Exports (in Local Currency Unit) of Hong Kong in 2011 and the Exports (in Local Currency Unit) of Ukraine in 2012?
Ensure brevity in your answer.  3.69e+12. What is the difference between the Exports (in Local Currency Unit) of Montenegro in 2011 and the Exports (in Local Currency Unit) of Nepal in 2012?
Your answer should be very brief. -1.52e+11. What is the difference between the Exports (in Local Currency Unit) in Montenegro in 2011 and the Exports (in Local Currency Unit) in Ukraine in 2012?
Keep it short and to the point. -6.69e+11. What is the difference between the Exports (in Local Currency Unit) of Nepal in 2011 and the Exports (in Local Currency Unit) of Ukraine in 2012?
Your response must be concise. -5.49e+11. What is the difference between the Exports (in Local Currency Unit) of Hong Kong in 2011 and the Exports (in Local Currency Unit) of Montenegro in 2013?
Ensure brevity in your answer.  4.36e+12. What is the difference between the Exports (in Local Currency Unit) of Hong Kong in 2011 and the Exports (in Local Currency Unit) of Nepal in 2013?
Provide a short and direct response. 4.18e+12. What is the difference between the Exports (in Local Currency Unit) of Hong Kong in 2011 and the Exports (in Local Currency Unit) of Ukraine in 2013?
Make the answer very short. 3.73e+12. What is the difference between the Exports (in Local Currency Unit) in Montenegro in 2011 and the Exports (in Local Currency Unit) in Nepal in 2013?
Provide a succinct answer. -1.80e+11. What is the difference between the Exports (in Local Currency Unit) in Montenegro in 2011 and the Exports (in Local Currency Unit) in Ukraine in 2013?
Provide a short and direct response. -6.28e+11. What is the difference between the Exports (in Local Currency Unit) of Nepal in 2011 and the Exports (in Local Currency Unit) of Ukraine in 2013?
Offer a terse response. -5.08e+11. What is the difference between the Exports (in Local Currency Unit) of Hong Kong in 2011 and the Exports (in Local Currency Unit) of Montenegro in 2014?
Provide a short and direct response. 4.36e+12. What is the difference between the Exports (in Local Currency Unit) of Hong Kong in 2011 and the Exports (in Local Currency Unit) of Nepal in 2014?
Give a very brief answer. 4.14e+12. What is the difference between the Exports (in Local Currency Unit) in Hong Kong in 2011 and the Exports (in Local Currency Unit) in Ukraine in 2014?
Your answer should be compact. 3.59e+12. What is the difference between the Exports (in Local Currency Unit) of Montenegro in 2011 and the Exports (in Local Currency Unit) of Nepal in 2014?
Provide a short and direct response. -2.25e+11. What is the difference between the Exports (in Local Currency Unit) in Montenegro in 2011 and the Exports (in Local Currency Unit) in Ukraine in 2014?
Make the answer very short. -7.69e+11. What is the difference between the Exports (in Local Currency Unit) in Nepal in 2011 and the Exports (in Local Currency Unit) in Ukraine in 2014?
Give a very brief answer. -6.48e+11. What is the difference between the Exports (in Local Currency Unit) in Hong Kong in 2012 and the Exports (in Local Currency Unit) in Montenegro in 2013?
Give a very brief answer. 4.59e+12. What is the difference between the Exports (in Local Currency Unit) in Hong Kong in 2012 and the Exports (in Local Currency Unit) in Nepal in 2013?
Give a very brief answer. 4.41e+12. What is the difference between the Exports (in Local Currency Unit) of Hong Kong in 2012 and the Exports (in Local Currency Unit) of Ukraine in 2013?
Ensure brevity in your answer.  3.97e+12. What is the difference between the Exports (in Local Currency Unit) in Montenegro in 2012 and the Exports (in Local Currency Unit) in Nepal in 2013?
Give a very brief answer. -1.80e+11. What is the difference between the Exports (in Local Currency Unit) of Montenegro in 2012 and the Exports (in Local Currency Unit) of Ukraine in 2013?
Offer a very short reply. -6.28e+11. What is the difference between the Exports (in Local Currency Unit) of Nepal in 2012 and the Exports (in Local Currency Unit) of Ukraine in 2013?
Your response must be concise. -4.76e+11. What is the difference between the Exports (in Local Currency Unit) of Hong Kong in 2012 and the Exports (in Local Currency Unit) of Montenegro in 2014?
Give a very brief answer. 4.59e+12. What is the difference between the Exports (in Local Currency Unit) in Hong Kong in 2012 and the Exports (in Local Currency Unit) in Nepal in 2014?
Give a very brief answer. 4.37e+12. What is the difference between the Exports (in Local Currency Unit) in Hong Kong in 2012 and the Exports (in Local Currency Unit) in Ukraine in 2014?
Offer a very short reply. 3.82e+12. What is the difference between the Exports (in Local Currency Unit) in Montenegro in 2012 and the Exports (in Local Currency Unit) in Nepal in 2014?
Provide a succinct answer. -2.25e+11. What is the difference between the Exports (in Local Currency Unit) in Montenegro in 2012 and the Exports (in Local Currency Unit) in Ukraine in 2014?
Keep it short and to the point. -7.69e+11. What is the difference between the Exports (in Local Currency Unit) in Nepal in 2012 and the Exports (in Local Currency Unit) in Ukraine in 2014?
Your answer should be very brief. -6.16e+11. What is the difference between the Exports (in Local Currency Unit) in Hong Kong in 2013 and the Exports (in Local Currency Unit) in Montenegro in 2014?
Provide a short and direct response. 4.87e+12. What is the difference between the Exports (in Local Currency Unit) of Hong Kong in 2013 and the Exports (in Local Currency Unit) of Nepal in 2014?
Your response must be concise. 4.65e+12. What is the difference between the Exports (in Local Currency Unit) in Hong Kong in 2013 and the Exports (in Local Currency Unit) in Ukraine in 2014?
Ensure brevity in your answer.  4.10e+12. What is the difference between the Exports (in Local Currency Unit) in Montenegro in 2013 and the Exports (in Local Currency Unit) in Nepal in 2014?
Give a very brief answer. -2.25e+11. What is the difference between the Exports (in Local Currency Unit) in Montenegro in 2013 and the Exports (in Local Currency Unit) in Ukraine in 2014?
Make the answer very short. -7.69e+11. What is the difference between the Exports (in Local Currency Unit) of Nepal in 2013 and the Exports (in Local Currency Unit) of Ukraine in 2014?
Your answer should be very brief. -5.89e+11. What is the average Exports (in Local Currency Unit) of Hong Kong per year?
Your answer should be compact. 4.10e+12. What is the average Exports (in Local Currency Unit) of Montenegro per year?
Offer a very short reply. 1.26e+09. What is the average Exports (in Local Currency Unit) in Nepal per year?
Your answer should be compact. 1.40e+11. What is the average Exports (in Local Currency Unit) in Ukraine per year?
Your answer should be very brief. 5.57e+11. In the year 2007, what is the difference between the Exports (in Local Currency Unit) of Hong Kong and Exports (in Local Currency Unit) of Montenegro?
Give a very brief answer. 3.36e+12. In the year 2007, what is the difference between the Exports (in Local Currency Unit) in Hong Kong and Exports (in Local Currency Unit) in Nepal?
Ensure brevity in your answer.  3.27e+12. In the year 2007, what is the difference between the Exports (in Local Currency Unit) of Hong Kong and Exports (in Local Currency Unit) of Ukraine?
Ensure brevity in your answer.  3.04e+12. In the year 2007, what is the difference between the Exports (in Local Currency Unit) of Montenegro and Exports (in Local Currency Unit) of Nepal?
Offer a terse response. -9.24e+1. In the year 2007, what is the difference between the Exports (in Local Currency Unit) of Montenegro and Exports (in Local Currency Unit) of Ukraine?
Your answer should be compact. -3.22e+11. In the year 2007, what is the difference between the Exports (in Local Currency Unit) of Nepal and Exports (in Local Currency Unit) of Ukraine?
Give a very brief answer. -2.30e+11. In the year 2008, what is the difference between the Exports (in Local Currency Unit) of Hong Kong and Exports (in Local Currency Unit) of Montenegro?
Your answer should be very brief. 3.56e+12. In the year 2008, what is the difference between the Exports (in Local Currency Unit) in Hong Kong and Exports (in Local Currency Unit) in Nepal?
Provide a short and direct response. 3.46e+12. In the year 2008, what is the difference between the Exports (in Local Currency Unit) of Hong Kong and Exports (in Local Currency Unit) of Ukraine?
Provide a short and direct response. 3.12e+12. In the year 2008, what is the difference between the Exports (in Local Currency Unit) of Montenegro and Exports (in Local Currency Unit) of Nepal?
Your answer should be very brief. -1.03e+11. In the year 2008, what is the difference between the Exports (in Local Currency Unit) of Montenegro and Exports (in Local Currency Unit) of Ukraine?
Provide a succinct answer. -4.44e+11. In the year 2008, what is the difference between the Exports (in Local Currency Unit) of Nepal and Exports (in Local Currency Unit) of Ukraine?
Your answer should be very brief. -3.41e+11. In the year 2009, what is the difference between the Exports (in Local Currency Unit) in Hong Kong and Exports (in Local Currency Unit) in Montenegro?
Make the answer very short. 3.17e+12. In the year 2009, what is the difference between the Exports (in Local Currency Unit) of Hong Kong and Exports (in Local Currency Unit) of Nepal?
Your answer should be very brief. 3.05e+12. In the year 2009, what is the difference between the Exports (in Local Currency Unit) of Hong Kong and Exports (in Local Currency Unit) of Ukraine?
Offer a terse response. 2.75e+12. In the year 2009, what is the difference between the Exports (in Local Currency Unit) of Montenegro and Exports (in Local Currency Unit) of Nepal?
Your answer should be very brief. -1.22e+11. In the year 2009, what is the difference between the Exports (in Local Currency Unit) of Montenegro and Exports (in Local Currency Unit) of Ukraine?
Ensure brevity in your answer.  -4.23e+11. In the year 2009, what is the difference between the Exports (in Local Currency Unit) in Nepal and Exports (in Local Currency Unit) in Ukraine?
Keep it short and to the point. -3.01e+11. In the year 2010, what is the difference between the Exports (in Local Currency Unit) of Hong Kong and Exports (in Local Currency Unit) of Montenegro?
Your response must be concise. 3.90e+12. In the year 2010, what is the difference between the Exports (in Local Currency Unit) of Hong Kong and Exports (in Local Currency Unit) of Nepal?
Make the answer very short. 3.78e+12. In the year 2010, what is the difference between the Exports (in Local Currency Unit) of Hong Kong and Exports (in Local Currency Unit) of Ukraine?
Make the answer very short. 3.35e+12. In the year 2010, what is the difference between the Exports (in Local Currency Unit) in Montenegro and Exports (in Local Currency Unit) in Nepal?
Provide a succinct answer. -1.13e+11. In the year 2010, what is the difference between the Exports (in Local Currency Unit) in Montenegro and Exports (in Local Currency Unit) in Ukraine?
Keep it short and to the point. -5.48e+11. In the year 2010, what is the difference between the Exports (in Local Currency Unit) of Nepal and Exports (in Local Currency Unit) of Ukraine?
Make the answer very short. -4.35e+11. In the year 2011, what is the difference between the Exports (in Local Currency Unit) of Hong Kong and Exports (in Local Currency Unit) of Montenegro?
Provide a short and direct response. 4.36e+12. In the year 2011, what is the difference between the Exports (in Local Currency Unit) in Hong Kong and Exports (in Local Currency Unit) in Nepal?
Your answer should be compact. 4.24e+12. In the year 2011, what is the difference between the Exports (in Local Currency Unit) in Hong Kong and Exports (in Local Currency Unit) in Ukraine?
Offer a terse response. 3.71e+12. In the year 2011, what is the difference between the Exports (in Local Currency Unit) in Montenegro and Exports (in Local Currency Unit) in Nepal?
Your answer should be very brief. -1.20e+11. In the year 2011, what is the difference between the Exports (in Local Currency Unit) of Montenegro and Exports (in Local Currency Unit) of Ukraine?
Provide a short and direct response. -6.46e+11. In the year 2011, what is the difference between the Exports (in Local Currency Unit) in Nepal and Exports (in Local Currency Unit) in Ukraine?
Offer a very short reply. -5.26e+11. In the year 2012, what is the difference between the Exports (in Local Currency Unit) in Hong Kong and Exports (in Local Currency Unit) in Montenegro?
Provide a succinct answer. 4.59e+12. In the year 2012, what is the difference between the Exports (in Local Currency Unit) of Hong Kong and Exports (in Local Currency Unit) of Nepal?
Ensure brevity in your answer.  4.44e+12. In the year 2012, what is the difference between the Exports (in Local Currency Unit) of Hong Kong and Exports (in Local Currency Unit) of Ukraine?
Your response must be concise. 3.92e+12. In the year 2012, what is the difference between the Exports (in Local Currency Unit) of Montenegro and Exports (in Local Currency Unit) of Nepal?
Make the answer very short. -1.52e+11. In the year 2012, what is the difference between the Exports (in Local Currency Unit) in Montenegro and Exports (in Local Currency Unit) in Ukraine?
Provide a succinct answer. -6.69e+11. In the year 2012, what is the difference between the Exports (in Local Currency Unit) in Nepal and Exports (in Local Currency Unit) in Ukraine?
Provide a succinct answer. -5.16e+11. In the year 2013, what is the difference between the Exports (in Local Currency Unit) in Hong Kong and Exports (in Local Currency Unit) in Montenegro?
Provide a succinct answer. 4.87e+12. In the year 2013, what is the difference between the Exports (in Local Currency Unit) of Hong Kong and Exports (in Local Currency Unit) of Nepal?
Offer a terse response. 4.69e+12. In the year 2013, what is the difference between the Exports (in Local Currency Unit) in Hong Kong and Exports (in Local Currency Unit) in Ukraine?
Provide a short and direct response. 4.25e+12. In the year 2013, what is the difference between the Exports (in Local Currency Unit) in Montenegro and Exports (in Local Currency Unit) in Nepal?
Your answer should be very brief. -1.80e+11. In the year 2013, what is the difference between the Exports (in Local Currency Unit) in Montenegro and Exports (in Local Currency Unit) in Ukraine?
Offer a very short reply. -6.28e+11. In the year 2013, what is the difference between the Exports (in Local Currency Unit) of Nepal and Exports (in Local Currency Unit) of Ukraine?
Your answer should be compact. -4.48e+11. In the year 2014, what is the difference between the Exports (in Local Currency Unit) in Hong Kong and Exports (in Local Currency Unit) in Montenegro?
Make the answer very short. 4.95e+12. In the year 2014, what is the difference between the Exports (in Local Currency Unit) in Hong Kong and Exports (in Local Currency Unit) in Nepal?
Provide a short and direct response. 4.73e+12. In the year 2014, what is the difference between the Exports (in Local Currency Unit) of Hong Kong and Exports (in Local Currency Unit) of Ukraine?
Keep it short and to the point. 4.18e+12. In the year 2014, what is the difference between the Exports (in Local Currency Unit) of Montenegro and Exports (in Local Currency Unit) of Nepal?
Your answer should be very brief. -2.25e+11. In the year 2014, what is the difference between the Exports (in Local Currency Unit) in Montenegro and Exports (in Local Currency Unit) in Ukraine?
Your response must be concise. -7.69e+11. In the year 2014, what is the difference between the Exports (in Local Currency Unit) of Nepal and Exports (in Local Currency Unit) of Ukraine?
Keep it short and to the point. -5.44e+11. What is the ratio of the Exports (in Local Currency Unit) of Hong Kong in 2007 to that in 2008?
Give a very brief answer. 0.94. What is the ratio of the Exports (in Local Currency Unit) in Montenegro in 2007 to that in 2008?
Make the answer very short. 0.98. What is the ratio of the Exports (in Local Currency Unit) in Nepal in 2007 to that in 2008?
Offer a terse response. 0.9. What is the ratio of the Exports (in Local Currency Unit) in Ukraine in 2007 to that in 2008?
Give a very brief answer. 0.73. What is the ratio of the Exports (in Local Currency Unit) of Hong Kong in 2007 to that in 2009?
Keep it short and to the point. 1.06. What is the ratio of the Exports (in Local Currency Unit) in Montenegro in 2007 to that in 2009?
Keep it short and to the point. 1.24. What is the ratio of the Exports (in Local Currency Unit) in Nepal in 2007 to that in 2009?
Ensure brevity in your answer.  0.76. What is the ratio of the Exports (in Local Currency Unit) in Ukraine in 2007 to that in 2009?
Keep it short and to the point. 0.76. What is the ratio of the Exports (in Local Currency Unit) in Hong Kong in 2007 to that in 2010?
Ensure brevity in your answer.  0.86. What is the ratio of the Exports (in Local Currency Unit) in Montenegro in 2007 to that in 2010?
Your answer should be compact. 1.03. What is the ratio of the Exports (in Local Currency Unit) of Nepal in 2007 to that in 2010?
Your response must be concise. 0.82. What is the ratio of the Exports (in Local Currency Unit) in Ukraine in 2007 to that in 2010?
Provide a short and direct response. 0.59. What is the ratio of the Exports (in Local Currency Unit) in Hong Kong in 2007 to that in 2011?
Offer a terse response. 0.77. What is the ratio of the Exports (in Local Currency Unit) of Montenegro in 2007 to that in 2011?
Offer a very short reply. 0.86. What is the ratio of the Exports (in Local Currency Unit) of Nepal in 2007 to that in 2011?
Provide a succinct answer. 0.77. What is the ratio of the Exports (in Local Currency Unit) in Ukraine in 2007 to that in 2011?
Make the answer very short. 0.5. What is the ratio of the Exports (in Local Currency Unit) in Hong Kong in 2007 to that in 2012?
Offer a terse response. 0.73. What is the ratio of the Exports (in Local Currency Unit) in Montenegro in 2007 to that in 2012?
Your response must be concise. 0.86. What is the ratio of the Exports (in Local Currency Unit) in Nepal in 2007 to that in 2012?
Keep it short and to the point. 0.61. What is the ratio of the Exports (in Local Currency Unit) of Ukraine in 2007 to that in 2012?
Provide a short and direct response. 0.48. What is the ratio of the Exports (in Local Currency Unit) in Hong Kong in 2007 to that in 2013?
Keep it short and to the point. 0.69. What is the ratio of the Exports (in Local Currency Unit) in Montenegro in 2007 to that in 2013?
Make the answer very short. 0.86. What is the ratio of the Exports (in Local Currency Unit) of Nepal in 2007 to that in 2013?
Make the answer very short. 0.52. What is the ratio of the Exports (in Local Currency Unit) of Ukraine in 2007 to that in 2013?
Your answer should be compact. 0.51. What is the ratio of the Exports (in Local Currency Unit) of Hong Kong in 2007 to that in 2014?
Your response must be concise. 0.68. What is the ratio of the Exports (in Local Currency Unit) in Montenegro in 2007 to that in 2014?
Offer a terse response. 0.86. What is the ratio of the Exports (in Local Currency Unit) of Nepal in 2007 to that in 2014?
Provide a short and direct response. 0.41. What is the ratio of the Exports (in Local Currency Unit) in Ukraine in 2007 to that in 2014?
Give a very brief answer. 0.42. What is the ratio of the Exports (in Local Currency Unit) in Hong Kong in 2008 to that in 2009?
Offer a very short reply. 1.12. What is the ratio of the Exports (in Local Currency Unit) of Montenegro in 2008 to that in 2009?
Provide a short and direct response. 1.27. What is the ratio of the Exports (in Local Currency Unit) of Nepal in 2008 to that in 2009?
Provide a short and direct response. 0.85. What is the ratio of the Exports (in Local Currency Unit) of Ukraine in 2008 to that in 2009?
Keep it short and to the point. 1.05. What is the ratio of the Exports (in Local Currency Unit) in Hong Kong in 2008 to that in 2010?
Your answer should be very brief. 0.91. What is the ratio of the Exports (in Local Currency Unit) of Montenegro in 2008 to that in 2010?
Offer a terse response. 1.05. What is the ratio of the Exports (in Local Currency Unit) of Nepal in 2008 to that in 2010?
Your response must be concise. 0.91. What is the ratio of the Exports (in Local Currency Unit) in Ukraine in 2008 to that in 2010?
Ensure brevity in your answer.  0.81. What is the ratio of the Exports (in Local Currency Unit) of Hong Kong in 2008 to that in 2011?
Offer a very short reply. 0.82. What is the ratio of the Exports (in Local Currency Unit) of Montenegro in 2008 to that in 2011?
Give a very brief answer. 0.88. What is the ratio of the Exports (in Local Currency Unit) of Nepal in 2008 to that in 2011?
Your answer should be compact. 0.86. What is the ratio of the Exports (in Local Currency Unit) of Ukraine in 2008 to that in 2011?
Your answer should be very brief. 0.69. What is the ratio of the Exports (in Local Currency Unit) of Hong Kong in 2008 to that in 2012?
Keep it short and to the point. 0.78. What is the ratio of the Exports (in Local Currency Unit) of Montenegro in 2008 to that in 2012?
Your response must be concise. 0.88. What is the ratio of the Exports (in Local Currency Unit) in Nepal in 2008 to that in 2012?
Ensure brevity in your answer.  0.68. What is the ratio of the Exports (in Local Currency Unit) in Ukraine in 2008 to that in 2012?
Offer a terse response. 0.66. What is the ratio of the Exports (in Local Currency Unit) of Hong Kong in 2008 to that in 2013?
Provide a succinct answer. 0.73. What is the ratio of the Exports (in Local Currency Unit) in Montenegro in 2008 to that in 2013?
Offer a very short reply. 0.88. What is the ratio of the Exports (in Local Currency Unit) in Nepal in 2008 to that in 2013?
Offer a terse response. 0.58. What is the ratio of the Exports (in Local Currency Unit) in Ukraine in 2008 to that in 2013?
Your response must be concise. 0.71. What is the ratio of the Exports (in Local Currency Unit) of Hong Kong in 2008 to that in 2014?
Offer a very short reply. 0.72. What is the ratio of the Exports (in Local Currency Unit) of Montenegro in 2008 to that in 2014?
Give a very brief answer. 0.88. What is the ratio of the Exports (in Local Currency Unit) of Nepal in 2008 to that in 2014?
Make the answer very short. 0.46. What is the ratio of the Exports (in Local Currency Unit) in Ukraine in 2008 to that in 2014?
Your answer should be very brief. 0.58. What is the ratio of the Exports (in Local Currency Unit) in Hong Kong in 2009 to that in 2010?
Offer a terse response. 0.81. What is the ratio of the Exports (in Local Currency Unit) of Montenegro in 2009 to that in 2010?
Provide a short and direct response. 0.83. What is the ratio of the Exports (in Local Currency Unit) in Nepal in 2009 to that in 2010?
Provide a short and direct response. 1.07. What is the ratio of the Exports (in Local Currency Unit) of Ukraine in 2009 to that in 2010?
Your answer should be very brief. 0.77. What is the ratio of the Exports (in Local Currency Unit) of Hong Kong in 2009 to that in 2011?
Your answer should be compact. 0.73. What is the ratio of the Exports (in Local Currency Unit) in Montenegro in 2009 to that in 2011?
Offer a very short reply. 0.69. What is the ratio of the Exports (in Local Currency Unit) of Nepal in 2009 to that in 2011?
Keep it short and to the point. 1.01. What is the ratio of the Exports (in Local Currency Unit) in Ukraine in 2009 to that in 2011?
Provide a short and direct response. 0.65. What is the ratio of the Exports (in Local Currency Unit) in Hong Kong in 2009 to that in 2012?
Provide a succinct answer. 0.69. What is the ratio of the Exports (in Local Currency Unit) in Montenegro in 2009 to that in 2012?
Offer a terse response. 0.69. What is the ratio of the Exports (in Local Currency Unit) in Nepal in 2009 to that in 2012?
Your response must be concise. 0.8. What is the ratio of the Exports (in Local Currency Unit) of Ukraine in 2009 to that in 2012?
Provide a short and direct response. 0.63. What is the ratio of the Exports (in Local Currency Unit) in Hong Kong in 2009 to that in 2013?
Make the answer very short. 0.65. What is the ratio of the Exports (in Local Currency Unit) in Montenegro in 2009 to that in 2013?
Keep it short and to the point. 0.69. What is the ratio of the Exports (in Local Currency Unit) in Nepal in 2009 to that in 2013?
Provide a succinct answer. 0.68. What is the ratio of the Exports (in Local Currency Unit) of Ukraine in 2009 to that in 2013?
Provide a short and direct response. 0.67. What is the ratio of the Exports (in Local Currency Unit) of Hong Kong in 2009 to that in 2014?
Your response must be concise. 0.64. What is the ratio of the Exports (in Local Currency Unit) of Montenegro in 2009 to that in 2014?
Your answer should be very brief. 0.69. What is the ratio of the Exports (in Local Currency Unit) of Nepal in 2009 to that in 2014?
Your response must be concise. 0.54. What is the ratio of the Exports (in Local Currency Unit) of Ukraine in 2009 to that in 2014?
Your response must be concise. 0.55. What is the ratio of the Exports (in Local Currency Unit) in Hong Kong in 2010 to that in 2011?
Ensure brevity in your answer.  0.89. What is the ratio of the Exports (in Local Currency Unit) in Montenegro in 2010 to that in 2011?
Provide a short and direct response. 0.84. What is the ratio of the Exports (in Local Currency Unit) of Nepal in 2010 to that in 2011?
Your answer should be very brief. 0.94. What is the ratio of the Exports (in Local Currency Unit) of Ukraine in 2010 to that in 2011?
Keep it short and to the point. 0.85. What is the ratio of the Exports (in Local Currency Unit) in Hong Kong in 2010 to that in 2012?
Your answer should be compact. 0.85. What is the ratio of the Exports (in Local Currency Unit) of Montenegro in 2010 to that in 2012?
Keep it short and to the point. 0.83. What is the ratio of the Exports (in Local Currency Unit) of Nepal in 2010 to that in 2012?
Ensure brevity in your answer.  0.74. What is the ratio of the Exports (in Local Currency Unit) in Ukraine in 2010 to that in 2012?
Your response must be concise. 0.82. What is the ratio of the Exports (in Local Currency Unit) of Hong Kong in 2010 to that in 2013?
Make the answer very short. 0.8. What is the ratio of the Exports (in Local Currency Unit) of Montenegro in 2010 to that in 2013?
Provide a succinct answer. 0.83. What is the ratio of the Exports (in Local Currency Unit) in Nepal in 2010 to that in 2013?
Make the answer very short. 0.63. What is the ratio of the Exports (in Local Currency Unit) in Ukraine in 2010 to that in 2013?
Ensure brevity in your answer.  0.87. What is the ratio of the Exports (in Local Currency Unit) in Hong Kong in 2010 to that in 2014?
Keep it short and to the point. 0.79. What is the ratio of the Exports (in Local Currency Unit) of Montenegro in 2010 to that in 2014?
Offer a terse response. 0.83. What is the ratio of the Exports (in Local Currency Unit) of Nepal in 2010 to that in 2014?
Your answer should be very brief. 0.51. What is the ratio of the Exports (in Local Currency Unit) in Ukraine in 2010 to that in 2014?
Provide a short and direct response. 0.71. What is the ratio of the Exports (in Local Currency Unit) in Hong Kong in 2011 to that in 2012?
Give a very brief answer. 0.95. What is the ratio of the Exports (in Local Currency Unit) in Nepal in 2011 to that in 2012?
Offer a terse response. 0.79. What is the ratio of the Exports (in Local Currency Unit) of Ukraine in 2011 to that in 2012?
Keep it short and to the point. 0.97. What is the ratio of the Exports (in Local Currency Unit) in Hong Kong in 2011 to that in 2013?
Your answer should be compact. 0.89. What is the ratio of the Exports (in Local Currency Unit) of Montenegro in 2011 to that in 2013?
Your response must be concise. 0.99. What is the ratio of the Exports (in Local Currency Unit) of Nepal in 2011 to that in 2013?
Provide a succinct answer. 0.67. What is the ratio of the Exports (in Local Currency Unit) in Ukraine in 2011 to that in 2013?
Provide a short and direct response. 1.03. What is the ratio of the Exports (in Local Currency Unit) in Hong Kong in 2011 to that in 2014?
Provide a succinct answer. 0.88. What is the ratio of the Exports (in Local Currency Unit) of Nepal in 2011 to that in 2014?
Provide a short and direct response. 0.54. What is the ratio of the Exports (in Local Currency Unit) of Ukraine in 2011 to that in 2014?
Your answer should be very brief. 0.84. What is the ratio of the Exports (in Local Currency Unit) of Hong Kong in 2012 to that in 2013?
Ensure brevity in your answer.  0.94. What is the ratio of the Exports (in Local Currency Unit) of Nepal in 2012 to that in 2013?
Your answer should be compact. 0.85. What is the ratio of the Exports (in Local Currency Unit) in Ukraine in 2012 to that in 2013?
Provide a short and direct response. 1.06. What is the ratio of the Exports (in Local Currency Unit) of Hong Kong in 2012 to that in 2014?
Provide a short and direct response. 0.93. What is the ratio of the Exports (in Local Currency Unit) of Montenegro in 2012 to that in 2014?
Make the answer very short. 1. What is the ratio of the Exports (in Local Currency Unit) of Nepal in 2012 to that in 2014?
Your answer should be very brief. 0.68. What is the ratio of the Exports (in Local Currency Unit) of Ukraine in 2012 to that in 2014?
Make the answer very short. 0.87. What is the ratio of the Exports (in Local Currency Unit) of Hong Kong in 2013 to that in 2014?
Offer a very short reply. 0.98. What is the ratio of the Exports (in Local Currency Unit) of Nepal in 2013 to that in 2014?
Offer a very short reply. 0.8. What is the ratio of the Exports (in Local Currency Unit) in Ukraine in 2013 to that in 2014?
Make the answer very short. 0.82. What is the difference between the highest and the second highest Exports (in Local Currency Unit) in Hong Kong?
Give a very brief answer. 7.92e+1. What is the difference between the highest and the second highest Exports (in Local Currency Unit) in Montenegro?
Give a very brief answer. 6.99e+05. What is the difference between the highest and the second highest Exports (in Local Currency Unit) of Nepal?
Your answer should be compact. 4.48e+1. What is the difference between the highest and the second highest Exports (in Local Currency Unit) of Ukraine?
Make the answer very short. 9.98e+1. What is the difference between the highest and the lowest Exports (in Local Currency Unit) in Hong Kong?
Make the answer very short. 1.78e+12. What is the difference between the highest and the lowest Exports (in Local Currency Unit) of Montenegro?
Make the answer very short. 4.33e+08. What is the difference between the highest and the lowest Exports (in Local Currency Unit) of Nepal?
Offer a very short reply. 1.32e+11. What is the difference between the highest and the lowest Exports (in Local Currency Unit) in Ukraine?
Keep it short and to the point. 4.47e+11. 